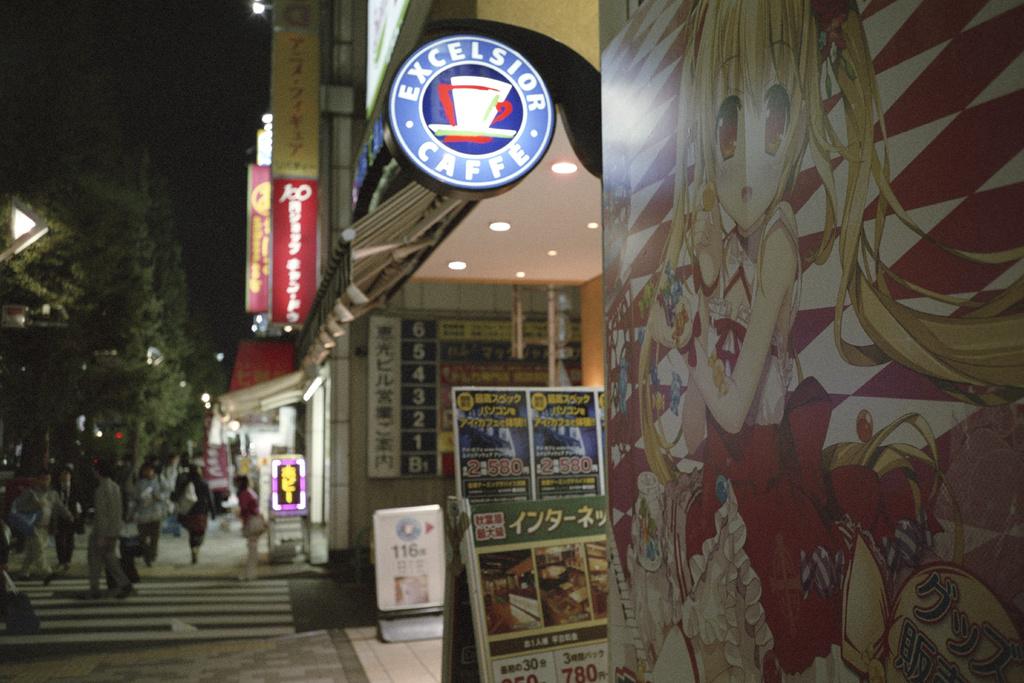What is the store name?
Give a very brief answer. Excelsior caffe. What kind of store is the one with the blue neon sign?
Offer a terse response. Cafe. 